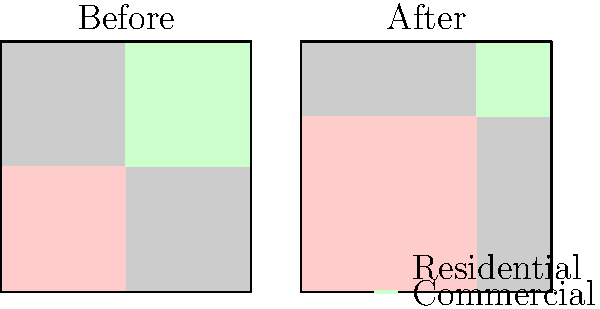Based on the before-and-after zoning maps, what percentage of the city's total area has been rezoned from commercial to residential use? How might this change impact local businesses and potentially violate existing property rights? To answer this question, we need to analyze the changes in zoning between the "Before" and "After" maps:

1. In the "Before" map, the city is divided equally between residential (red) and commercial (green) zones, each occupying 50% of the total area.

2. In the "After" map, the residential zone has expanded to cover approximately 70% of the total area, while the commercial zone has been reduced to about 30%.

3. To calculate the percentage of area rezoned from commercial to residential:
   - Original commercial area: 50%
   - New commercial area: 30%
   - Area rezoned: 50% - 30% = 20%

4. Impact on local businesses:
   - Reduction in available commercial space may lead to increased rent and property values in remaining commercial areas.
   - Some businesses may be forced to relocate or close due to rezoning.

5. Potential violation of property rights:
   - Property owners in rezoned areas may lose the right to use their property for commercial purposes.
   - This could be seen as a "regulatory taking" without just compensation, potentially violating the Fifth Amendment.

6. Legal considerations:
   - The city must demonstrate a valid public purpose for the rezoning.
   - Affected property owners may have grounds for legal challenge based on diminished property values or loss of business opportunities.
Answer: 20% rezoned; potential negative impact on businesses and property rights 